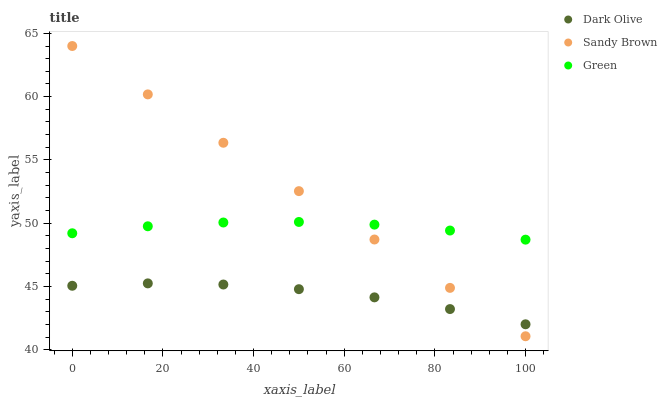Does Dark Olive have the minimum area under the curve?
Answer yes or no. Yes. Does Sandy Brown have the maximum area under the curve?
Answer yes or no. Yes. Does Sandy Brown have the minimum area under the curve?
Answer yes or no. No. Does Dark Olive have the maximum area under the curve?
Answer yes or no. No. Is Sandy Brown the smoothest?
Answer yes or no. Yes. Is Dark Olive the roughest?
Answer yes or no. Yes. Is Dark Olive the smoothest?
Answer yes or no. No. Is Sandy Brown the roughest?
Answer yes or no. No. Does Sandy Brown have the lowest value?
Answer yes or no. Yes. Does Dark Olive have the lowest value?
Answer yes or no. No. Does Sandy Brown have the highest value?
Answer yes or no. Yes. Does Dark Olive have the highest value?
Answer yes or no. No. Is Dark Olive less than Green?
Answer yes or no. Yes. Is Green greater than Dark Olive?
Answer yes or no. Yes. Does Sandy Brown intersect Green?
Answer yes or no. Yes. Is Sandy Brown less than Green?
Answer yes or no. No. Is Sandy Brown greater than Green?
Answer yes or no. No. Does Dark Olive intersect Green?
Answer yes or no. No. 